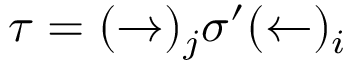<formula> <loc_0><loc_0><loc_500><loc_500>\tau = ( \rightarrow ) _ { j } \sigma ^ { \prime } ( \leftarrow ) _ { i }</formula> 